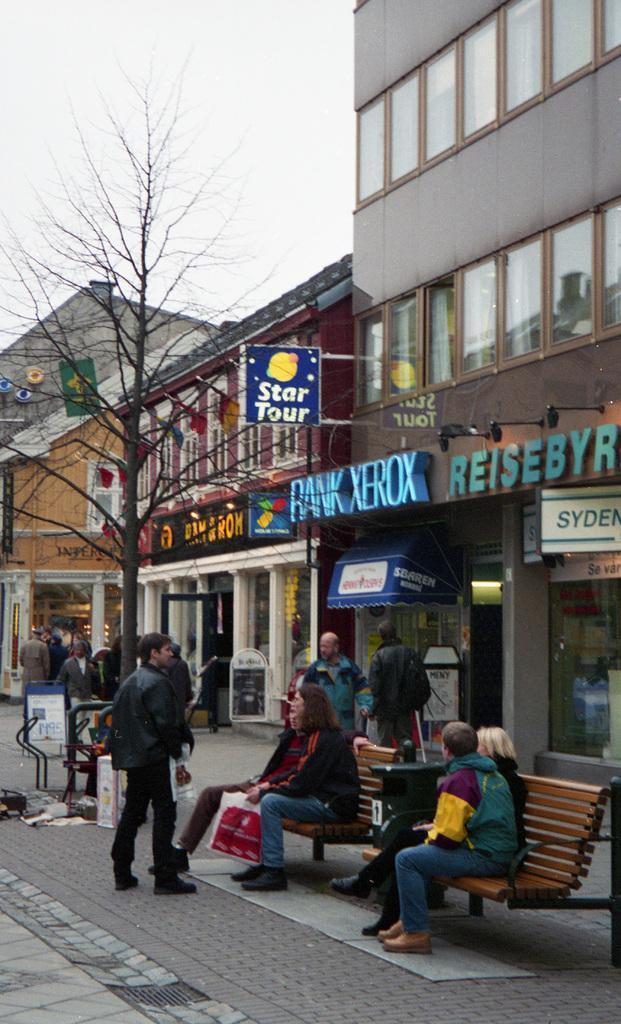Can you describe this image briefly? In this image i can see few persons sitting and few persons standing at the back ground i can see a tree, a stall,a building, a window and sky. 